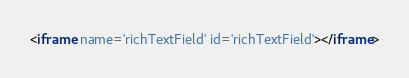Convert code to text. <code><loc_0><loc_0><loc_500><loc_500><_HTML_><iframe name='richTextField' id='richTextField'></iframe></code> 